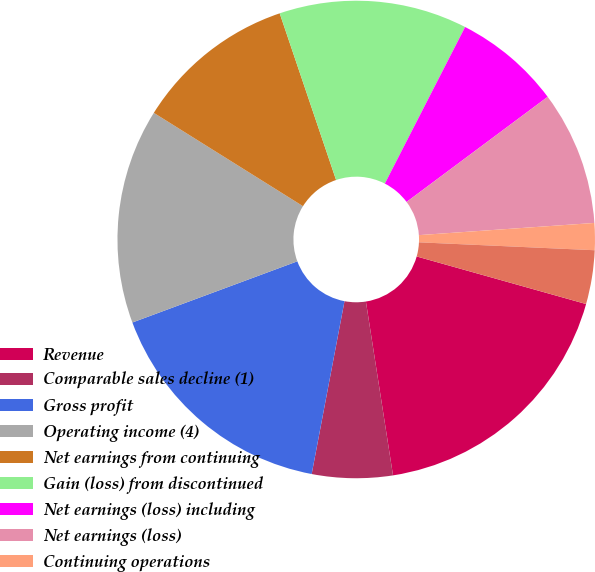<chart> <loc_0><loc_0><loc_500><loc_500><pie_chart><fcel>Revenue<fcel>Comparable sales decline (1)<fcel>Gross profit<fcel>Operating income (4)<fcel>Net earnings from continuing<fcel>Gain (loss) from discontinued<fcel>Net earnings (loss) including<fcel>Net earnings (loss)<fcel>Continuing operations<fcel>Discontinued operations<nl><fcel>18.18%<fcel>5.45%<fcel>16.36%<fcel>14.55%<fcel>10.91%<fcel>12.73%<fcel>7.27%<fcel>9.09%<fcel>1.82%<fcel>3.64%<nl></chart> 